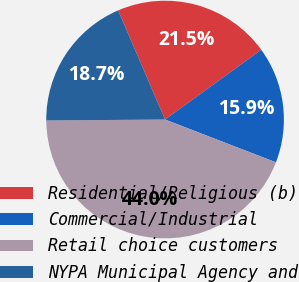Convert chart to OTSL. <chart><loc_0><loc_0><loc_500><loc_500><pie_chart><fcel>Residential/Religious (b)<fcel>Commercial/Industrial<fcel>Retail choice customers<fcel>NYPA Municipal Agency and<nl><fcel>21.48%<fcel>15.85%<fcel>44.01%<fcel>18.66%<nl></chart> 